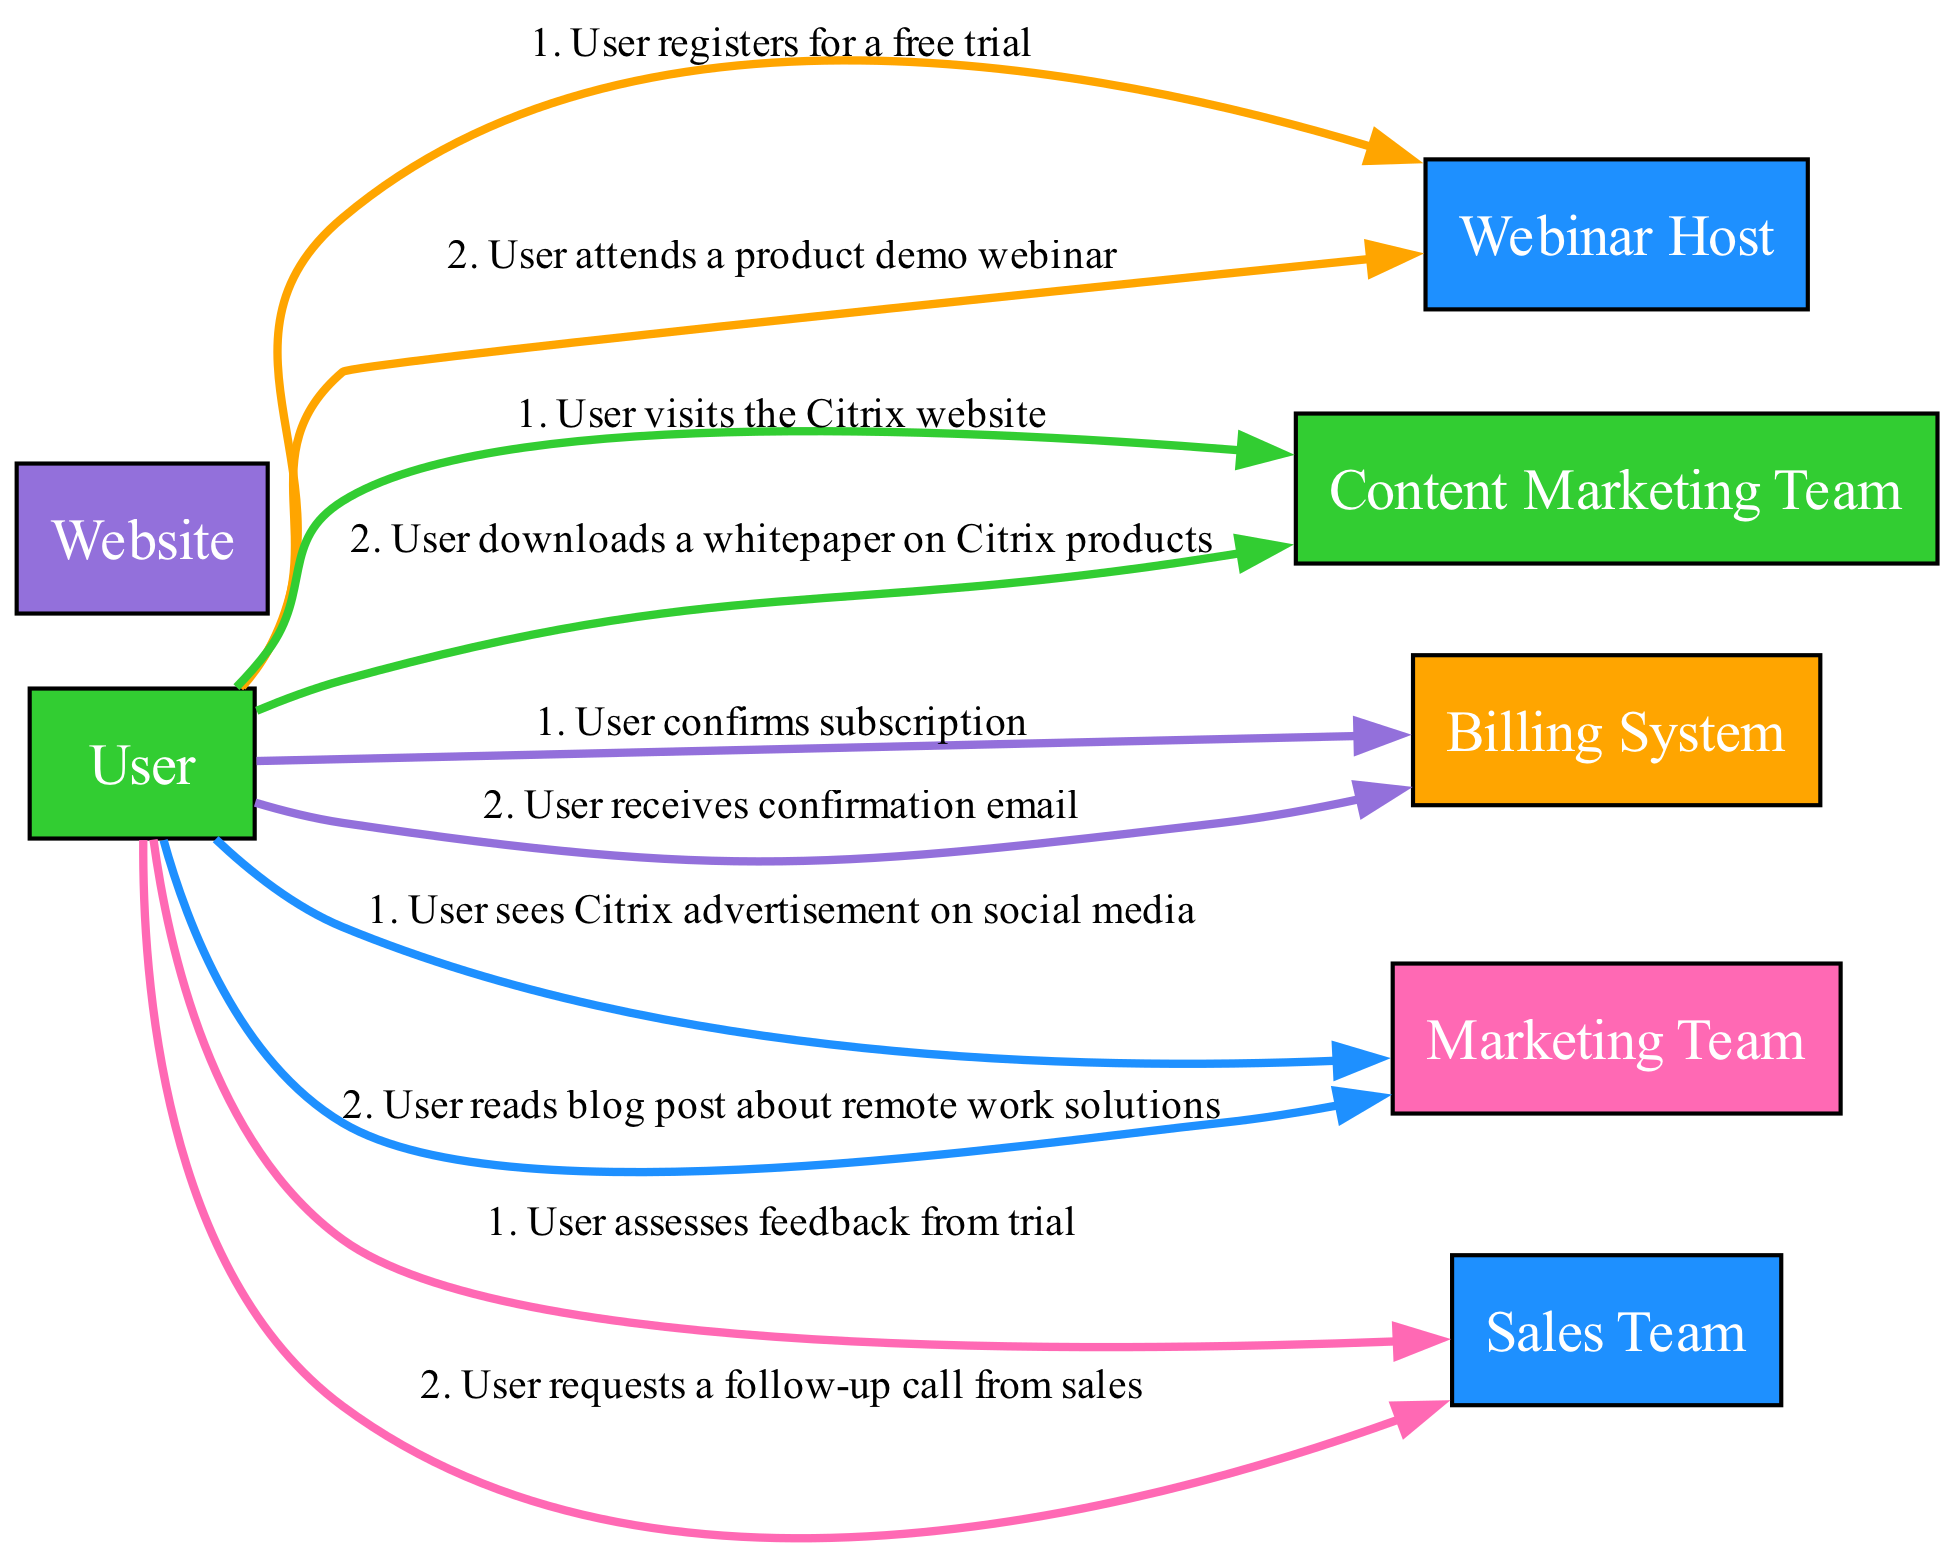What is the first stage of the user journey? The diagram shows that the first stage is labeled "Awareness." This is the initial point in the user journey where activities related to user awareness take place.
Answer: Awareness How many actions are listed under the "Evaluation" stage? By examining the actions listed under the "Evaluation" stage, there are two actions noted: "User registers for a free trial" and "User attends a product demo webinar." Thus, the total count of actions in this stage is two.
Answer: 2 Who is involved in the "Decision" stage? The "Decision" stage lists "User" and "Sales Team" as the participants. These participants engage during the evaluation of feedback and the request for a follow-up call.
Answer: User, Sales Team What action does the user take after the product demo webinar? From the "Evaluation" stage, after attending the product demo webinar, the user takes the action of "User registers for a free trial." This indicates the progression following the webinar.
Answer: User registers for a free trial Which team does the user interact with in the "Purchase" stage? In the "Purchase" stage, the user interacts with the "Sales Team" and "Billing System." These teams facilitate the subscription confirmation process.
Answer: Sales Team, Billing System What is the last action taken in the user journey? The final action in the user journey, as depicted in the "Purchase" stage, is "User receives confirmation email." This marks the conclusion of the user's interaction regarding the product evaluation.
Answer: User receives confirmation email How many participants are involved in the "Consideration" stage? The "Consideration" stage has three participants: "User," "Website," and "Content Marketing Team." The count of these distinct roles participating in this stage is three.
Answer: 3 What is the relationship between the "User" and the "Sales Team" in the "Decision" stage? In the "Decision" stage, the user assesses feedback from the trial and requests a follow-up call from the sales team. This shows a direct interaction where the user seeks further engagement from the sales team after their trial experience.
Answer: User requests a follow-up call from sales What color represents the "Awareness" stage? In the diagram, the "Awareness" stage is represented by a specific color, which is blue in the custom color scheme: "#1e90ff." This color coding helps distinguish the stage visually from others.
Answer: Blue 